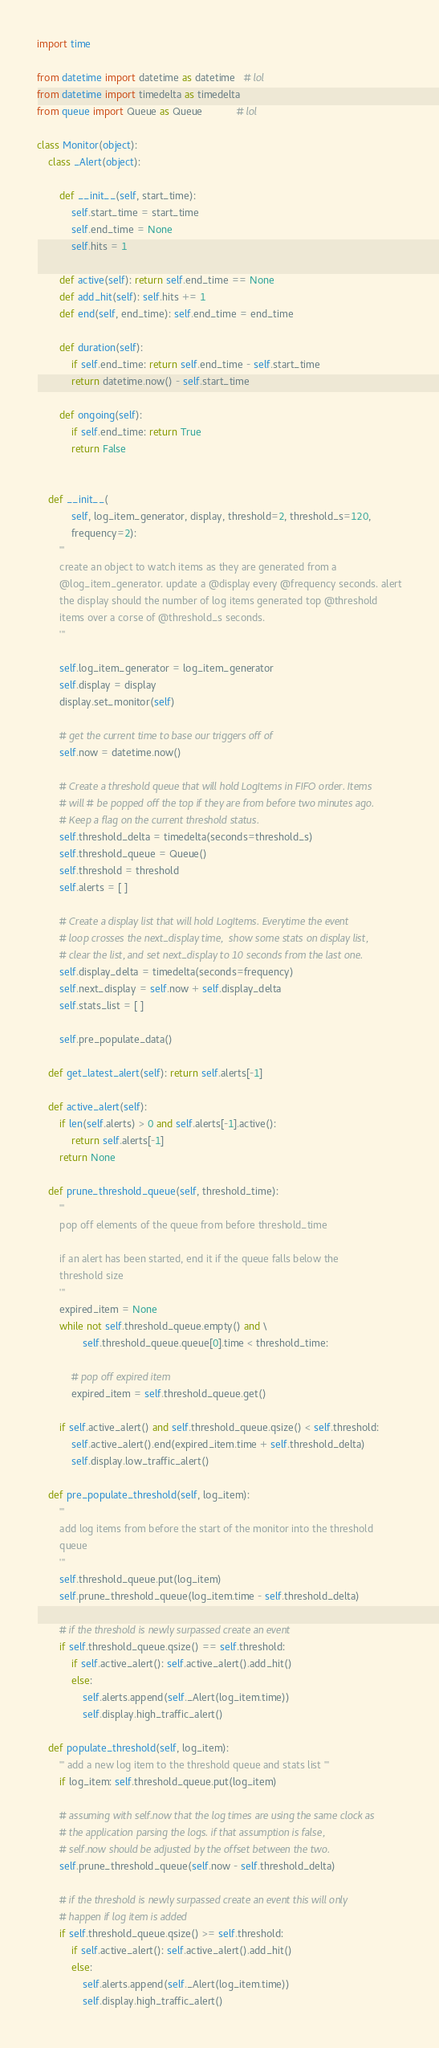Convert code to text. <code><loc_0><loc_0><loc_500><loc_500><_Python_>
import time

from datetime import datetime as datetime   # lol
from datetime import timedelta as timedelta 
from queue import Queue as Queue            # lol

class Monitor(object):
    class _Alert(object):

        def __init__(self, start_time):
            self.start_time = start_time
            self.end_time = None 
            self.hits = 1

        def active(self): return self.end_time == None
        def add_hit(self): self.hits += 1
        def end(self, end_time): self.end_time = end_time

        def duration(self):
            if self.end_time: return self.end_time - self.start_time
            return datetime.now() - self.start_time

        def ongoing(self):
            if self.end_time: return True
            return False


    def __init__(
            self, log_item_generator, display, threshold=2, threshold_s=120,
            frequency=2):
        '''
        create an object to watch items as they are generated from a
        @log_item_generator. update a @display every @frequency seconds. alert
        the display should the number of log items generated top @threshold
        items over a corse of @threshold_s seconds.
        '''

        self.log_item_generator = log_item_generator
        self.display = display
        display.set_monitor(self)

        # get the current time to base our triggers off of
        self.now = datetime.now()

        # Create a threshold queue that will hold LogItems in FIFO order. Items
        # will # be popped off the top if they are from before two minutes ago.
        # Keep a flag on the current threshold status.
        self.threshold_delta = timedelta(seconds=threshold_s)
        self.threshold_queue = Queue()
        self.threshold = threshold
        self.alerts = [ ] 

        # Create a display list that will hold LogItems. Everytime the event
        # loop crosses the next_display time,  show some stats on display list,
        # clear the list, and set next_display to 10 seconds from the last one.
        self.display_delta = timedelta(seconds=frequency)
        self.next_display = self.now + self.display_delta
        self.stats_list = [ ] 

        self.pre_populate_data()

    def get_latest_alert(self): return self.alerts[-1]

    def active_alert(self):
        if len(self.alerts) > 0 and self.alerts[-1].active():
            return self.alerts[-1]
        return None

    def prune_threshold_queue(self, threshold_time):
        '''
        pop off elements of the queue from before threshold_time

        if an alert has been started, end it if the queue falls below the 
        threshold size
        '''
        expired_item = None
        while not self.threshold_queue.empty() and \
                self.threshold_queue.queue[0].time < threshold_time:

            # pop off expired item
            expired_item = self.threshold_queue.get()

        if self.active_alert() and self.threshold_queue.qsize() < self.threshold:
            self.active_alert().end(expired_item.time + self.threshold_delta)
            self.display.low_traffic_alert()

    def pre_populate_threshold(self, log_item):
        '''
        add log items from before the start of the monitor into the threshold
        queue 
        '''
        self.threshold_queue.put(log_item)
        self.prune_threshold_queue(log_item.time - self.threshold_delta)

        # if the threshold is newly surpassed create an event
        if self.threshold_queue.qsize() == self.threshold:
            if self.active_alert(): self.active_alert().add_hit()
            else: 
                self.alerts.append(self._Alert(log_item.time))
                self.display.high_traffic_alert()

    def populate_threshold(self, log_item):
        ''' add a new log item to the threshold queue and stats list '''
        if log_item: self.threshold_queue.put(log_item)

        # assuming with self.now that the log times are using the same clock as
        # the application parsing the logs. if that assumption is false,
        # self.now should be adjusted by the offset between the two.
        self.prune_threshold_queue(self.now - self.threshold_delta)

        # if the threshold is newly surpassed create an event this will only
        # happen if log item is added
        if self.threshold_queue.qsize() >= self.threshold:
            if self.active_alert(): self.active_alert().add_hit()
            else:
                self.alerts.append(self._Alert(log_item.time))
                self.display.high_traffic_alert()
</code> 